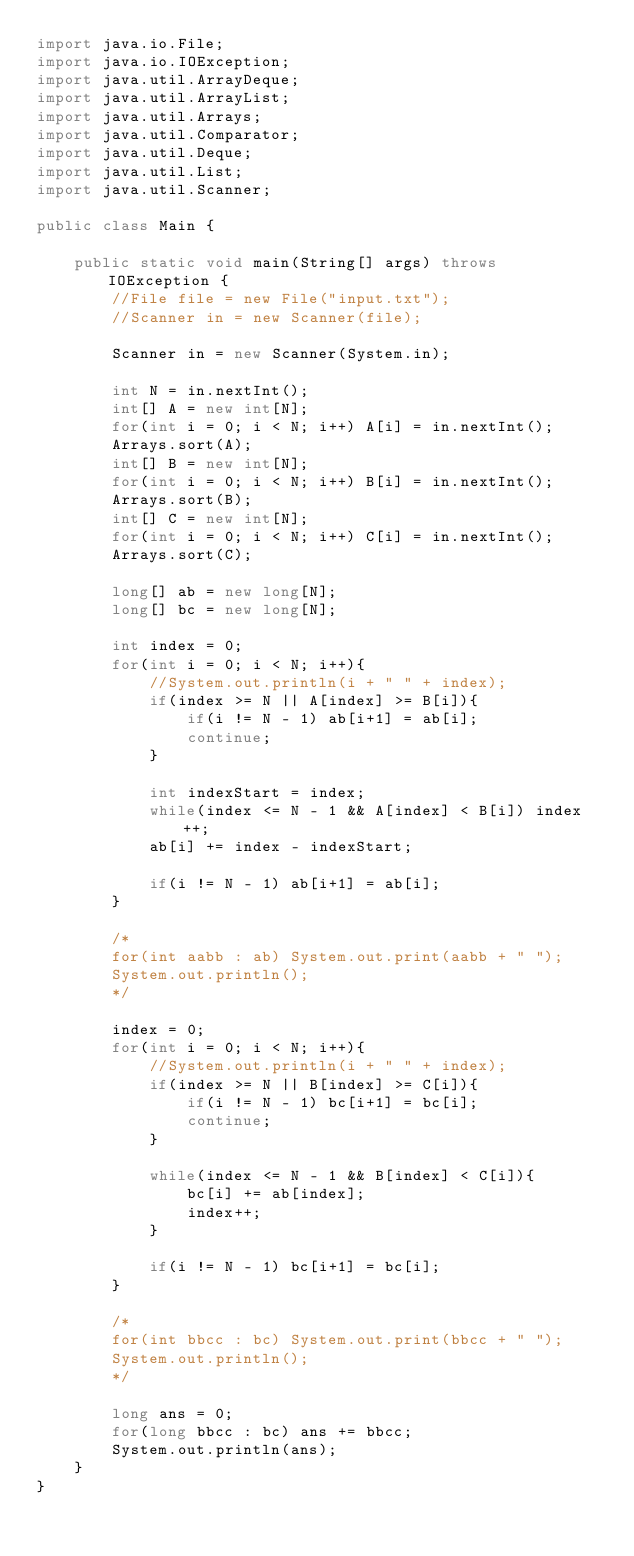<code> <loc_0><loc_0><loc_500><loc_500><_Java_>import java.io.File;
import java.io.IOException;
import java.util.ArrayDeque;
import java.util.ArrayList;
import java.util.Arrays;
import java.util.Comparator;
import java.util.Deque;
import java.util.List;
import java.util.Scanner;

public class Main {
 
	public static void main(String[] args) throws IOException {
		//File file = new File("input.txt");
		//Scanner in = new Scanner(file);
		
		Scanner in = new Scanner(System.in);

		int N = in.nextInt();
		int[] A = new int[N];
		for(int i = 0; i < N; i++) A[i] = in.nextInt();
		Arrays.sort(A);
		int[] B = new int[N];
		for(int i = 0; i < N; i++) B[i] = in.nextInt();
		Arrays.sort(B);
		int[] C = new int[N];
		for(int i = 0; i < N; i++) C[i] = in.nextInt();
		Arrays.sort(C);
		
		long[] ab = new long[N];
		long[] bc = new long[N];
		
		int index = 0;
		for(int i = 0; i < N; i++){
			//System.out.println(i + " " + index);
			if(index >= N || A[index] >= B[i]){
				if(i != N - 1) ab[i+1] = ab[i];
				continue;
			}
			
			int indexStart = index;
			while(index <= N - 1 && A[index] < B[i]) index++;
			ab[i] += index - indexStart;
			
			if(i != N - 1) ab[i+1] = ab[i];
		}
		
		/*
		for(int aabb : ab) System.out.print(aabb + " ");
		System.out.println();
		*/
		
		index = 0;
		for(int i = 0; i < N; i++){
			//System.out.println(i + " " + index);
			if(index >= N || B[index] >= C[i]){
				if(i != N - 1) bc[i+1] = bc[i];
				continue;
			}
			
			while(index <= N - 1 && B[index] < C[i]){
				bc[i] += ab[index];
				index++;
			}
			
			if(i != N - 1) bc[i+1] = bc[i];
		}
		
		/*
		for(int bbcc : bc) System.out.print(bbcc + " ");
		System.out.println();
		*/
		
		long ans = 0;
		for(long bbcc : bc) ans += bbcc;
		System.out.println(ans);
	}
}
</code> 